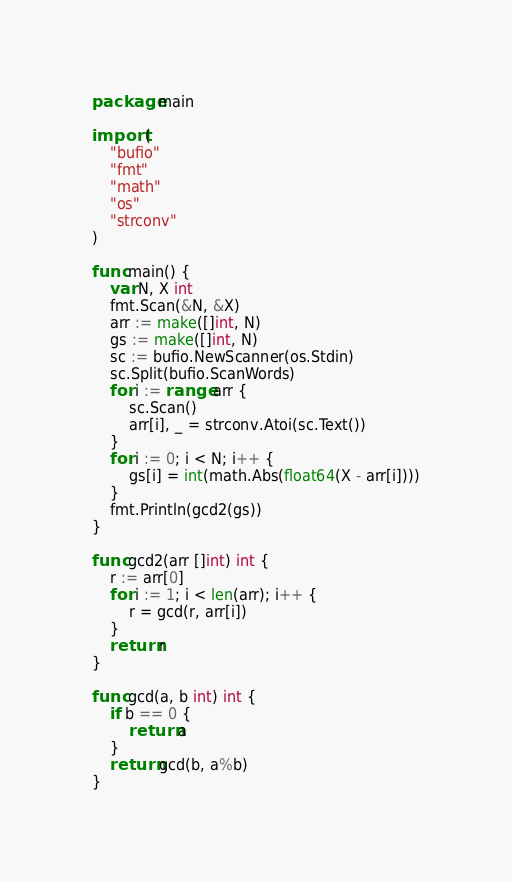<code> <loc_0><loc_0><loc_500><loc_500><_Go_>package main

import (
	"bufio"
	"fmt"
	"math"
	"os"
	"strconv"
)

func main() {
	var N, X int
	fmt.Scan(&N, &X)
	arr := make([]int, N)
	gs := make([]int, N)
	sc := bufio.NewScanner(os.Stdin)
	sc.Split(bufio.ScanWords)
	for i := range arr {
		sc.Scan()
		arr[i], _ = strconv.Atoi(sc.Text())
	}
	for i := 0; i < N; i++ {
		gs[i] = int(math.Abs(float64(X - arr[i])))
	}
	fmt.Println(gcd2(gs))
}

func gcd2(arr []int) int {
	r := arr[0]
	for i := 1; i < len(arr); i++ {
		r = gcd(r, arr[i])
	}
	return r
}

func gcd(a, b int) int {
	if b == 0 {
		return a
	}
	return gcd(b, a%b)
}</code> 